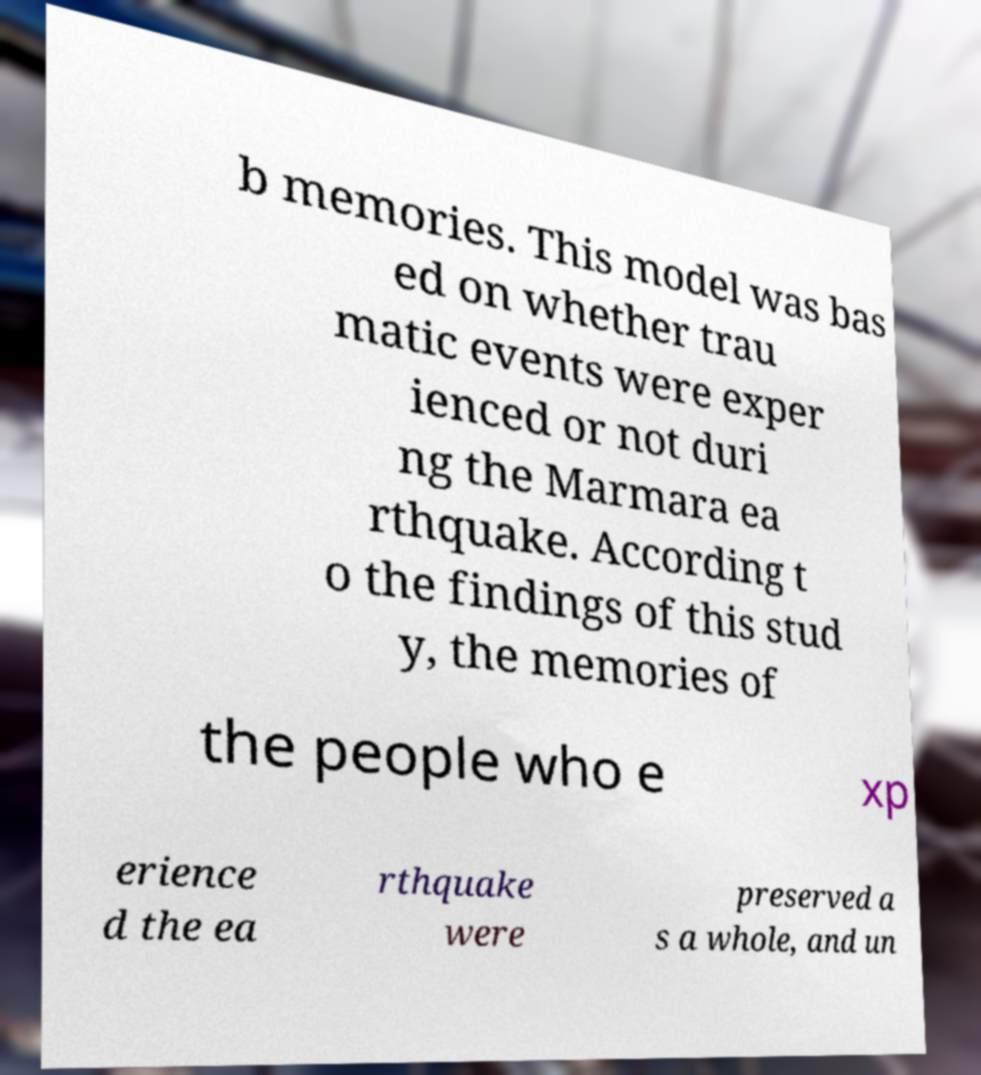For documentation purposes, I need the text within this image transcribed. Could you provide that? b memories. This model was bas ed on whether trau matic events were exper ienced or not duri ng the Marmara ea rthquake. According t o the findings of this stud y, the memories of the people who e xp erience d the ea rthquake were preserved a s a whole, and un 